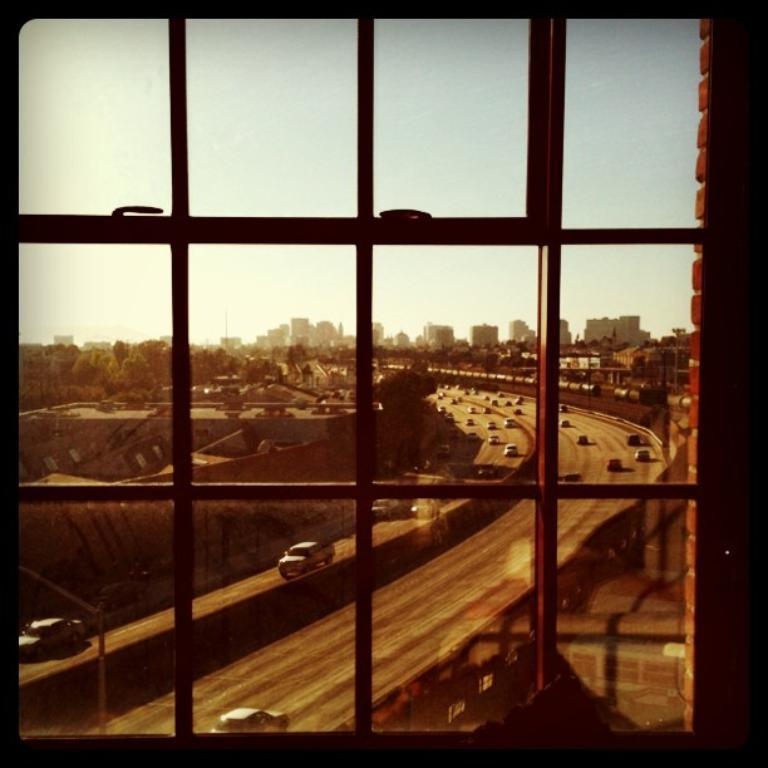What can be seen in the image that provides a view of the outdoors? There is a window in the image that provides a view of the outdoors. What is happening on the road in the image? There are vehicles on the road in the image. What type of structures can be seen in the image? There are buildings in the image. What type of vegetation is present in the image? There are trees in the image. What is visible in the background of the image? The sky is visible in the background of the image. Can you see a chicken wearing a crown in the image? There is no chicken or crown present in the image. How does the start of the race affect the vehicles in the image? There is no race or starting point mentioned in the image, so it's not possible to determine how it would affect the vehicles. 